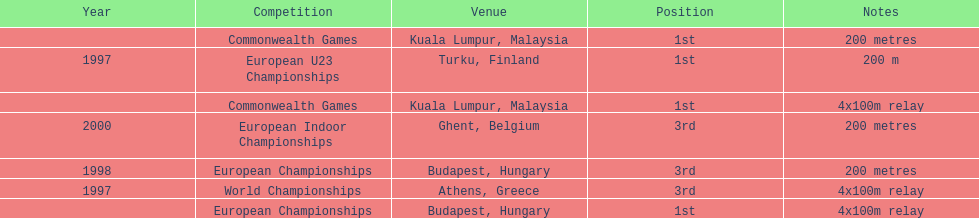How many competitions were in budapest, hungary and came in 1st position? 1. 